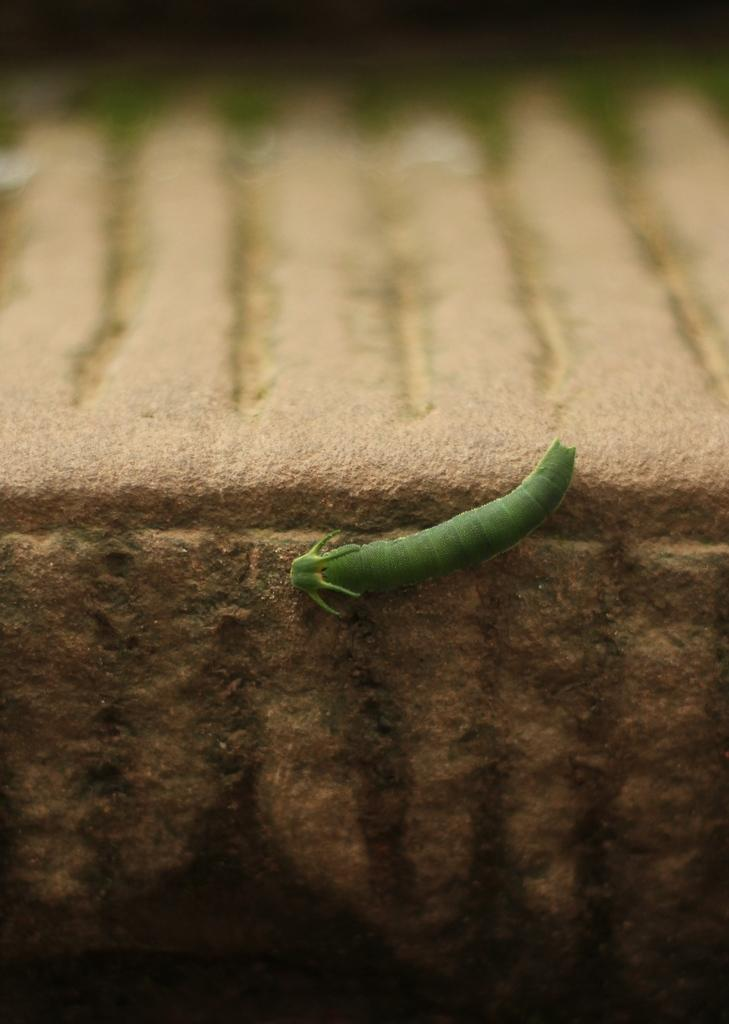What is the main subject of the image? The main subject of the image is a worm. Can you describe the appearance of the worm? The worm is green in color. Where is the worm located in the image? The worm is on the wall. What type of cracker is the worm holding in the image? There is no cracker present in the image, and the worm is not holding anything. 